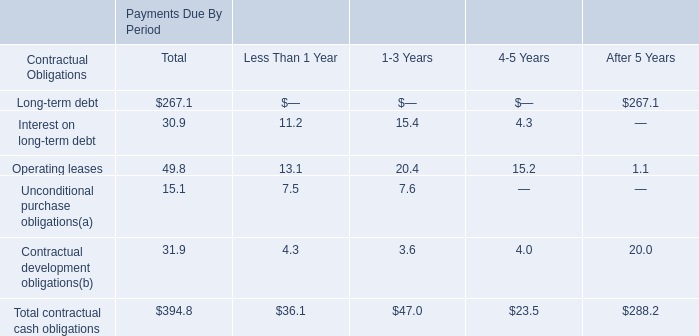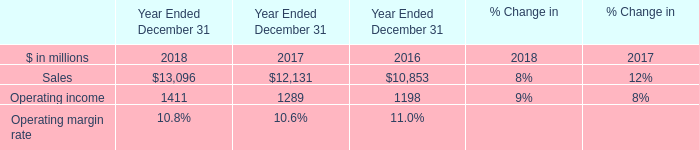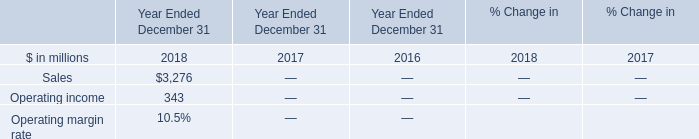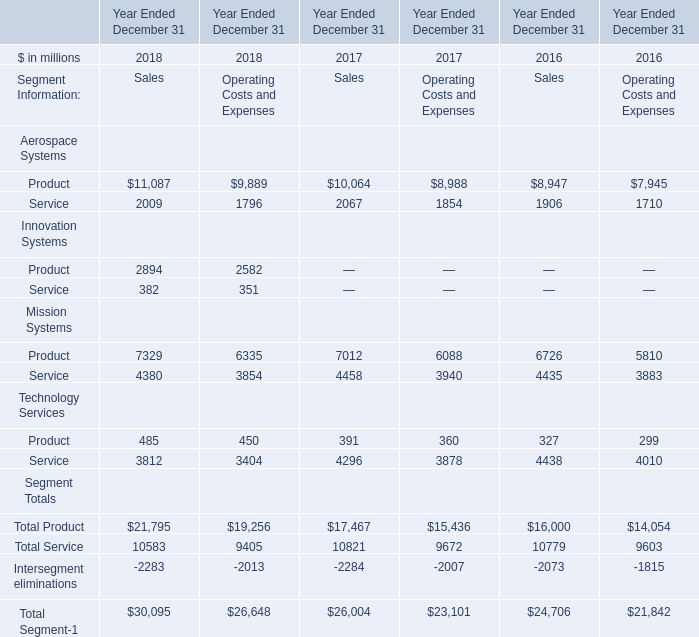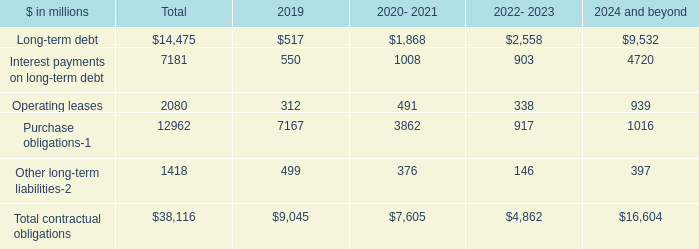What is the ratio of Operating income in Table 1 to the Sales in Table 2 in 2018? 
Computations: (1411 / 3276)
Answer: 0.43071. 